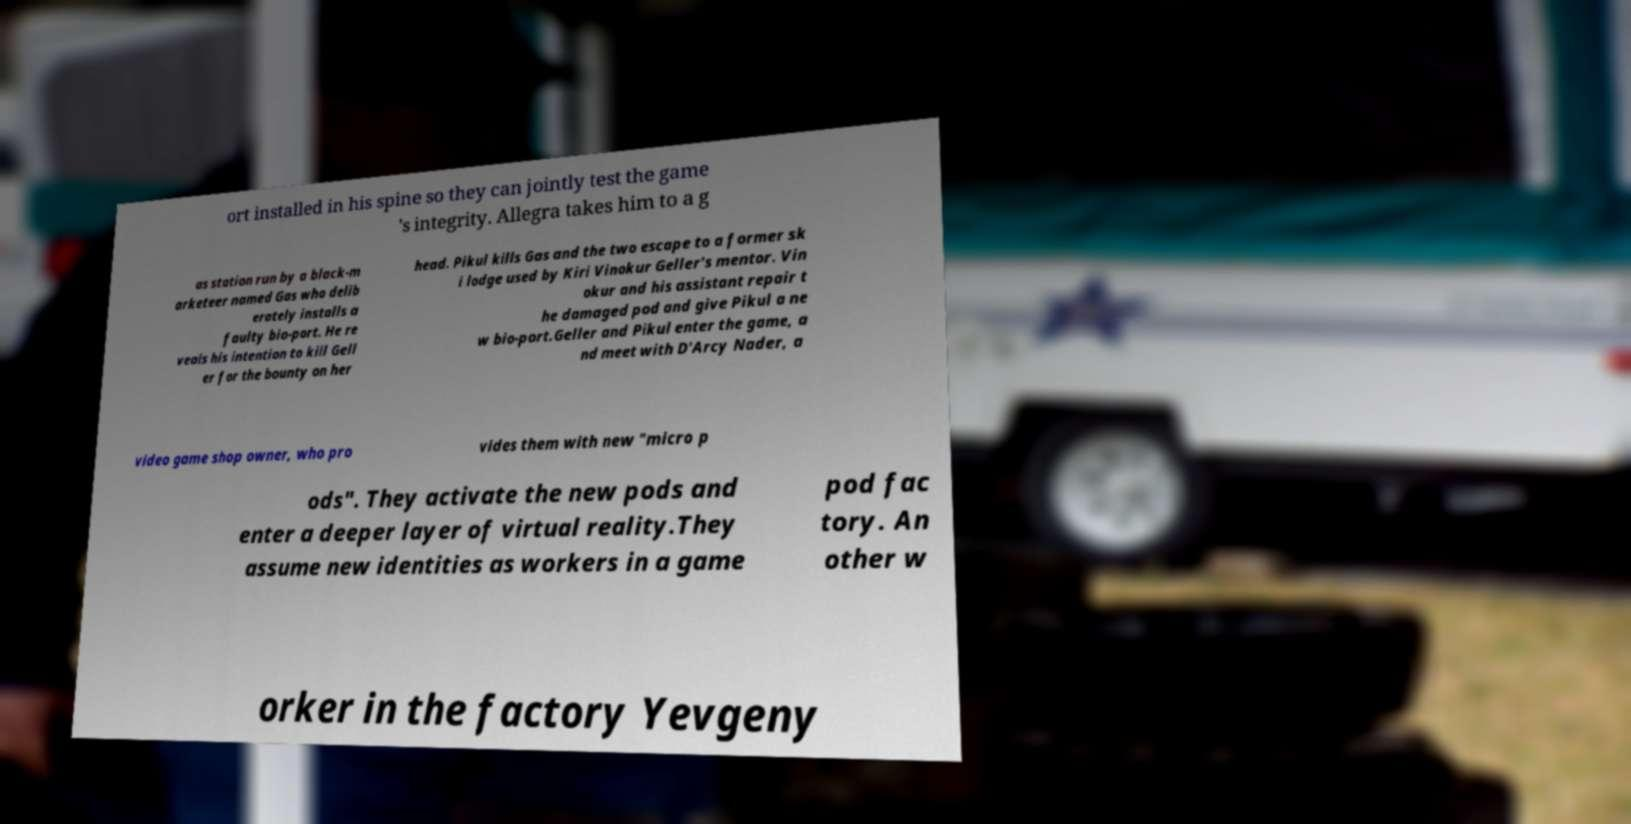Could you assist in decoding the text presented in this image and type it out clearly? ort installed in his spine so they can jointly test the game 's integrity. Allegra takes him to a g as station run by a black-m arketeer named Gas who delib erately installs a faulty bio-port. He re veals his intention to kill Gell er for the bounty on her head. Pikul kills Gas and the two escape to a former sk i lodge used by Kiri Vinokur Geller's mentor. Vin okur and his assistant repair t he damaged pod and give Pikul a ne w bio-port.Geller and Pikul enter the game, a nd meet with D'Arcy Nader, a video game shop owner, who pro vides them with new "micro p ods". They activate the new pods and enter a deeper layer of virtual reality.They assume new identities as workers in a game pod fac tory. An other w orker in the factory Yevgeny 